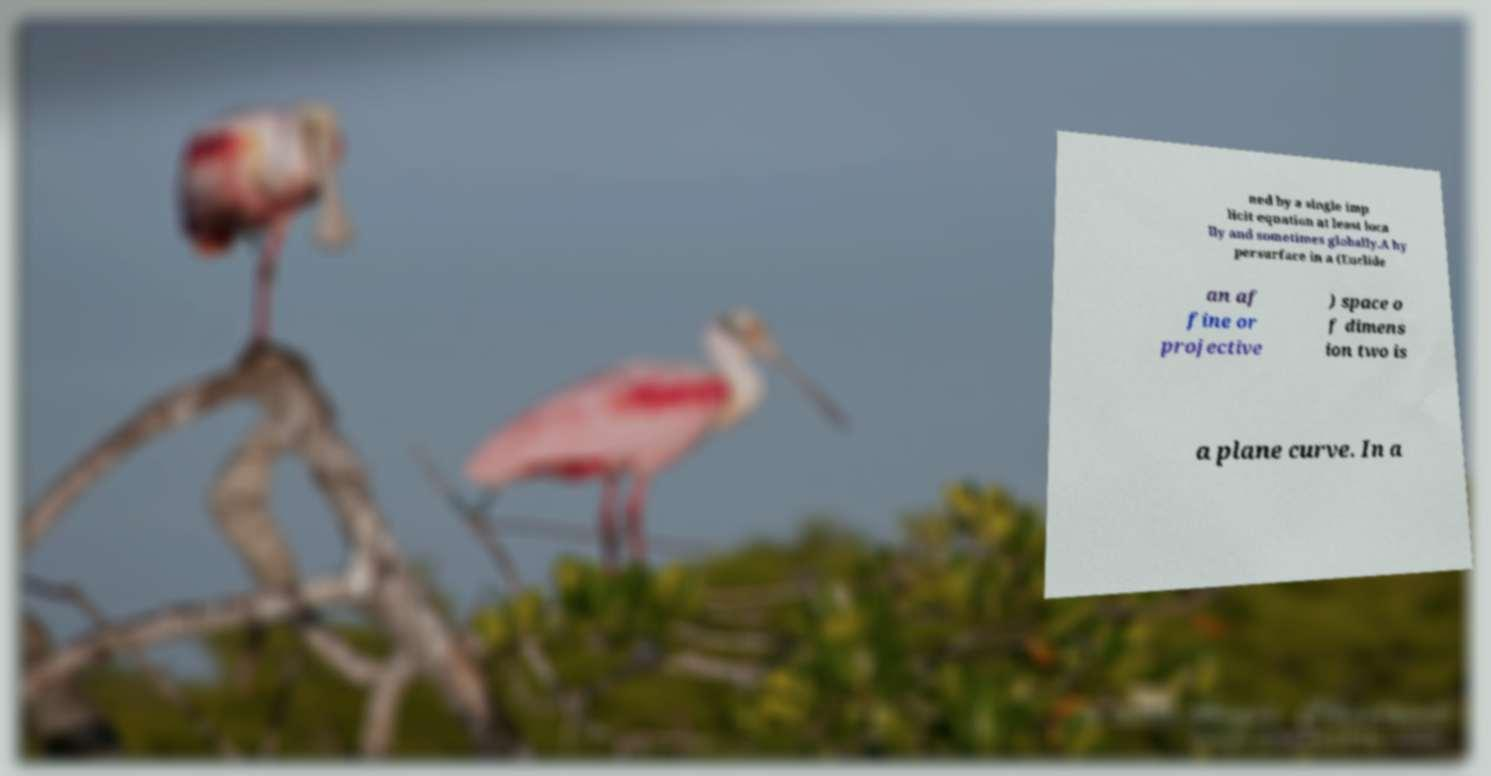Please read and relay the text visible in this image. What does it say? ned by a single imp licit equation at least loca lly and sometimes globally.A hy persurface in a (Euclide an af fine or projective ) space o f dimens ion two is a plane curve. In a 